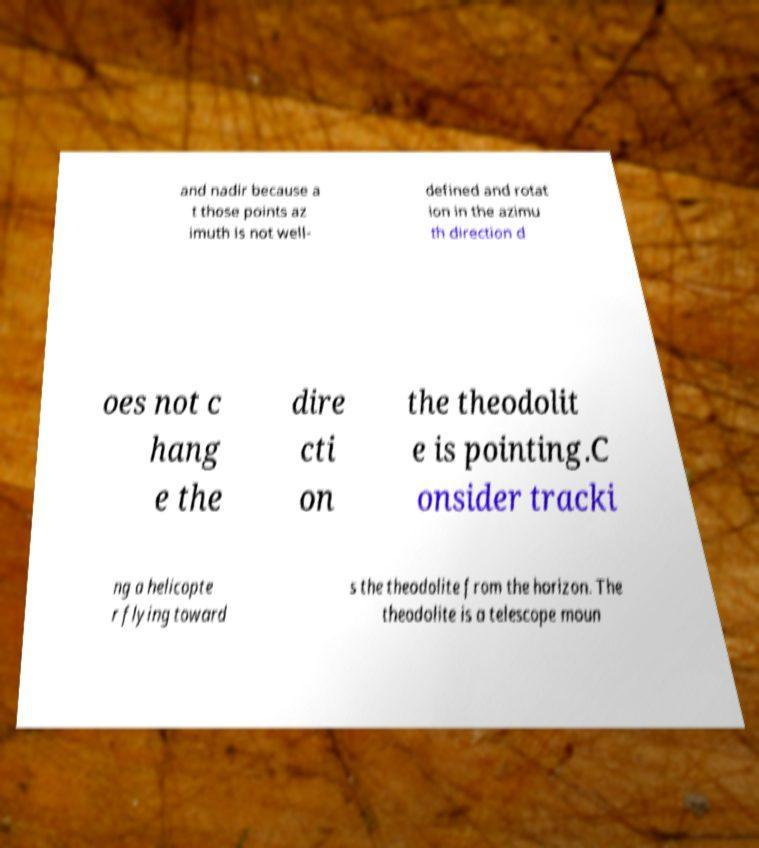Can you accurately transcribe the text from the provided image for me? and nadir because a t those points az imuth is not well- defined and rotat ion in the azimu th direction d oes not c hang e the dire cti on the theodolit e is pointing.C onsider tracki ng a helicopte r flying toward s the theodolite from the horizon. The theodolite is a telescope moun 